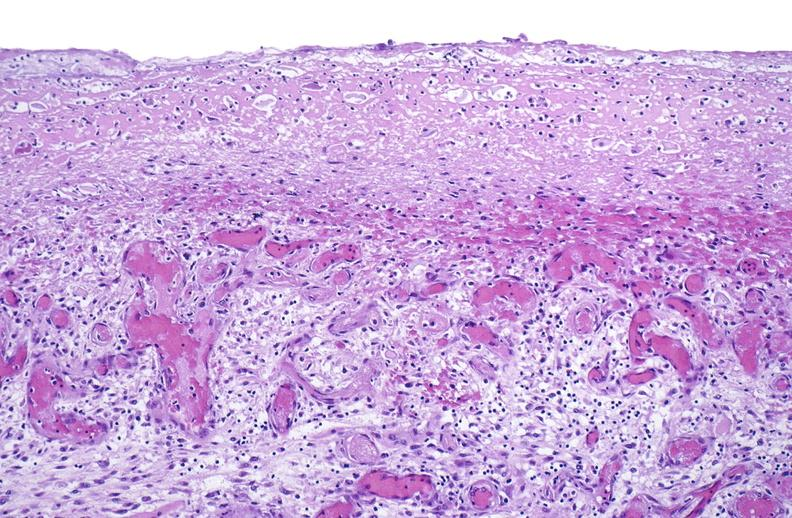s all the fat necrosis present?
Answer the question using a single word or phrase. No 